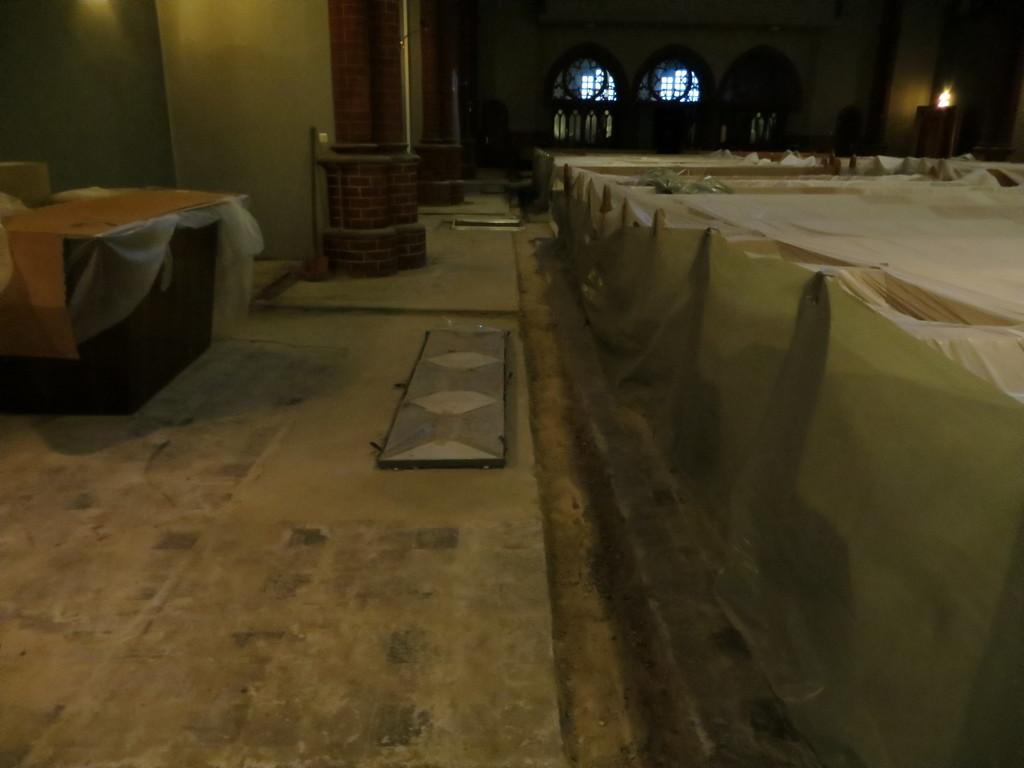What type of furniture is present on the right side of the image? There are chairs on the right side of the image. How are the chairs decorated in the image? The chairs are covered with white cloth. What is located on the left side of the image? There is a desk on the left side of the image. What is the background of the image? There is a wall in the image. What year is depicted on the wall in the image? There is no year visible on the wall in the image. What type of fruit is present on the desk in the image? There is no fruit, specifically an orange, present on the desk in the image. 